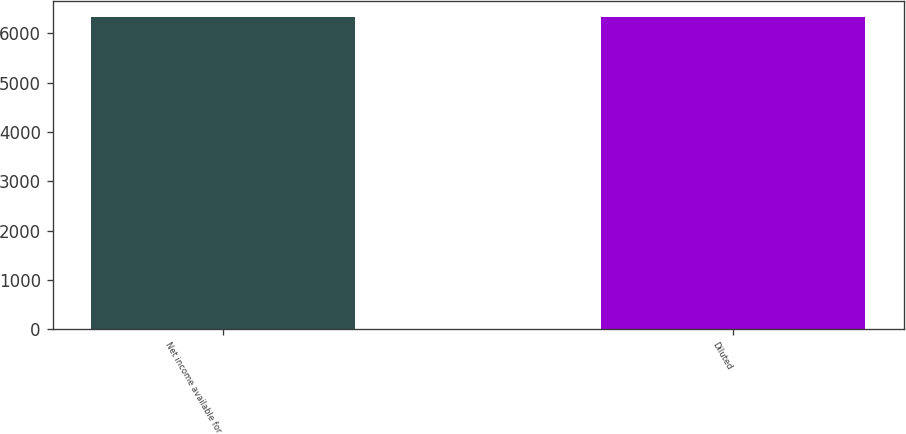<chart> <loc_0><loc_0><loc_500><loc_500><bar_chart><fcel>Net income available for<fcel>Diluted<nl><fcel>6323<fcel>6329<nl></chart> 